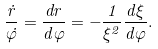Convert formula to latex. <formula><loc_0><loc_0><loc_500><loc_500>\frac { \dot { r } } { \dot { \varphi } } = \frac { d r } { d \varphi } = - \frac { 1 } { \xi ^ { 2 } } \frac { d \xi } { d \varphi } .</formula> 